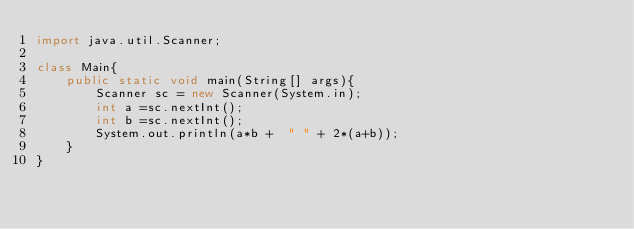<code> <loc_0><loc_0><loc_500><loc_500><_Java_>import java.util.Scanner;

class Main{
    public static void main(String[] args){
        Scanner sc = new Scanner(System.in);
        int a =sc.nextInt();
        int b =sc.nextInt();
        System.out.println(a*b +  " " + 2*(a+b));
    }
}
</code> 